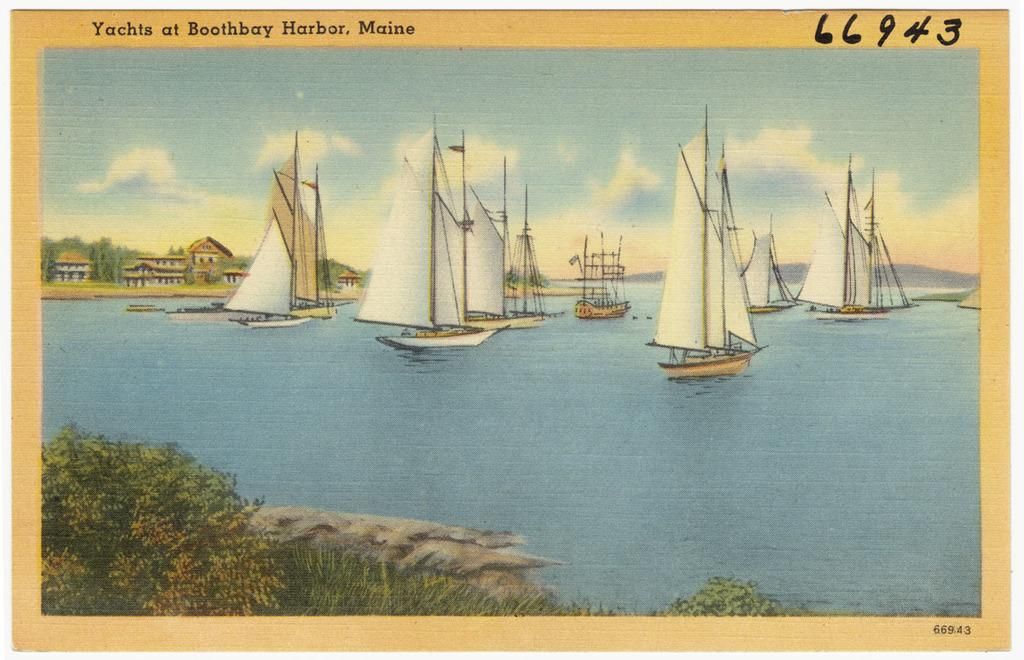<image>
Present a compact description of the photo's key features. A view of Boothbay harbor shows many boats on the water. 